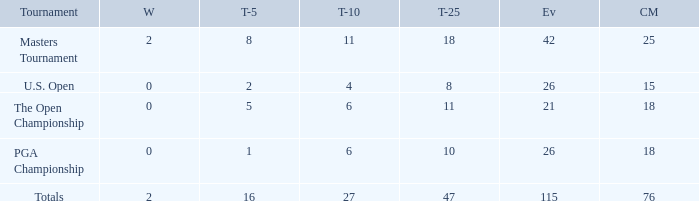What are the largest slashes made when the incidents are fewer than 21? None. 